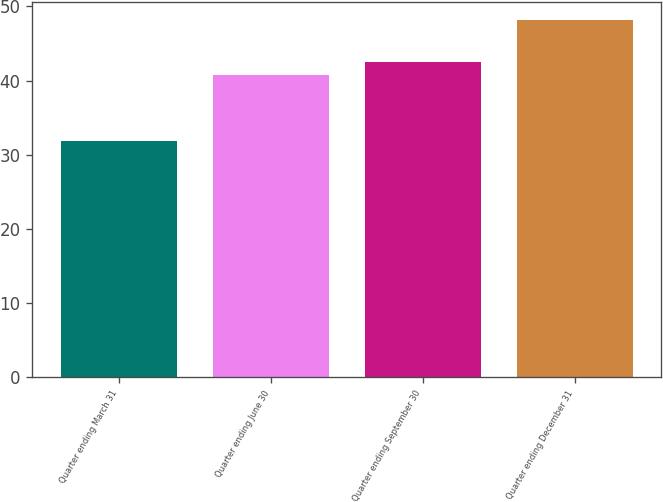Convert chart to OTSL. <chart><loc_0><loc_0><loc_500><loc_500><bar_chart><fcel>Quarter ending March 31<fcel>Quarter ending June 30<fcel>Quarter ending September 30<fcel>Quarter ending December 31<nl><fcel>31.84<fcel>40.82<fcel>42.45<fcel>48.18<nl></chart> 